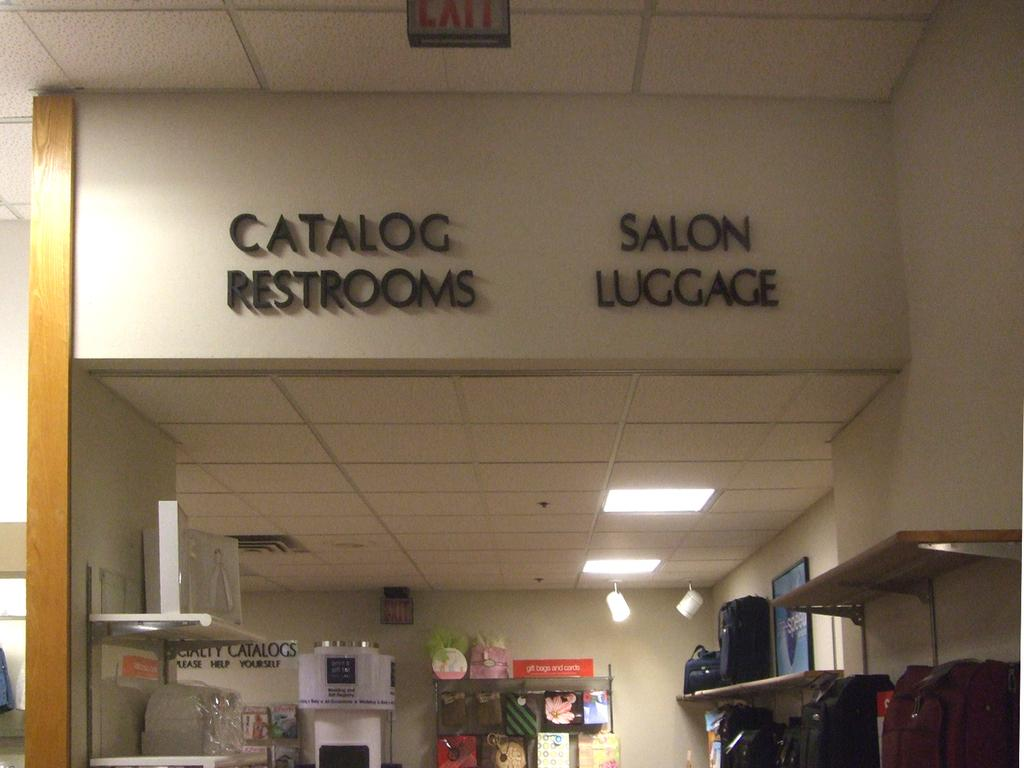<image>
Relay a brief, clear account of the picture shown. Entrance to a hop with black lettering shopping choices like luggage. 